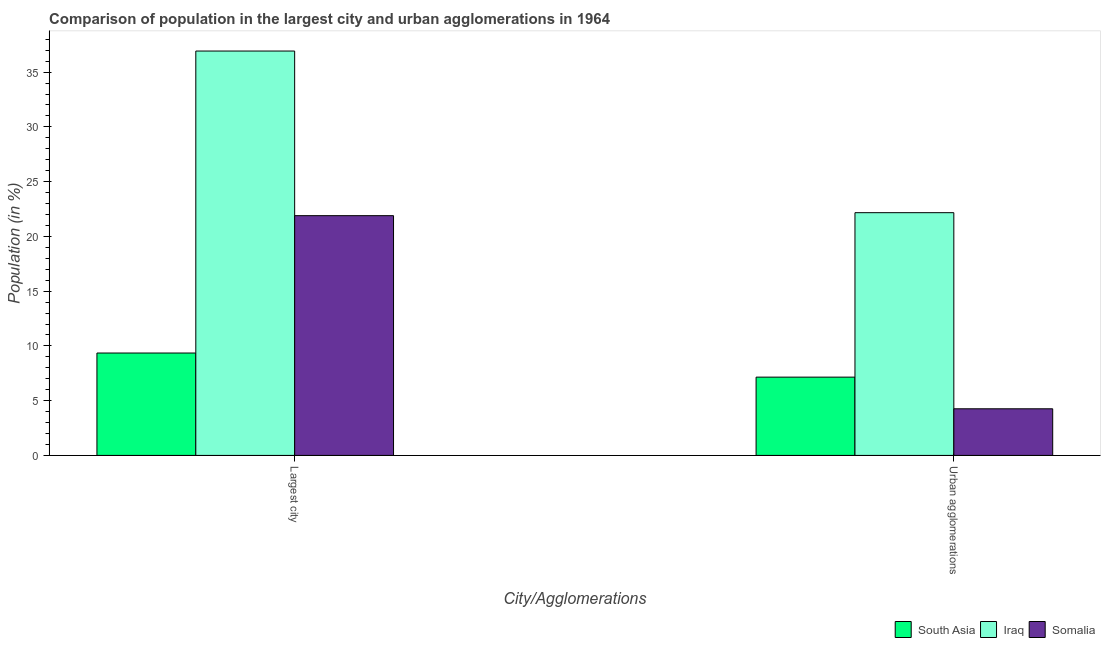How many different coloured bars are there?
Offer a very short reply. 3. How many groups of bars are there?
Give a very brief answer. 2. How many bars are there on the 2nd tick from the left?
Keep it short and to the point. 3. How many bars are there on the 2nd tick from the right?
Provide a short and direct response. 3. What is the label of the 1st group of bars from the left?
Give a very brief answer. Largest city. What is the population in urban agglomerations in Iraq?
Give a very brief answer. 22.17. Across all countries, what is the maximum population in the largest city?
Provide a short and direct response. 36.92. Across all countries, what is the minimum population in urban agglomerations?
Your answer should be compact. 4.26. In which country was the population in the largest city maximum?
Offer a very short reply. Iraq. In which country was the population in the largest city minimum?
Offer a very short reply. South Asia. What is the total population in urban agglomerations in the graph?
Your answer should be compact. 33.57. What is the difference between the population in urban agglomerations in Somalia and that in South Asia?
Offer a terse response. -2.89. What is the difference between the population in the largest city in Somalia and the population in urban agglomerations in South Asia?
Ensure brevity in your answer.  14.74. What is the average population in the largest city per country?
Your answer should be very brief. 22.72. What is the difference between the population in the largest city and population in urban agglomerations in Somalia?
Your answer should be compact. 17.63. What is the ratio of the population in urban agglomerations in Iraq to that in Somalia?
Ensure brevity in your answer.  5.2. In how many countries, is the population in the largest city greater than the average population in the largest city taken over all countries?
Offer a very short reply. 1. What does the 2nd bar from the left in Urban agglomerations represents?
Keep it short and to the point. Iraq. What does the 2nd bar from the right in Largest city represents?
Your response must be concise. Iraq. What is the difference between two consecutive major ticks on the Y-axis?
Make the answer very short. 5. Does the graph contain any zero values?
Provide a succinct answer. No. Does the graph contain grids?
Your answer should be compact. No. Where does the legend appear in the graph?
Offer a terse response. Bottom right. How are the legend labels stacked?
Your response must be concise. Horizontal. What is the title of the graph?
Provide a succinct answer. Comparison of population in the largest city and urban agglomerations in 1964. What is the label or title of the X-axis?
Give a very brief answer. City/Agglomerations. What is the Population (in %) of South Asia in Largest city?
Your response must be concise. 9.35. What is the Population (in %) in Iraq in Largest city?
Provide a short and direct response. 36.92. What is the Population (in %) of Somalia in Largest city?
Your answer should be very brief. 21.89. What is the Population (in %) of South Asia in Urban agglomerations?
Provide a short and direct response. 7.15. What is the Population (in %) of Iraq in Urban agglomerations?
Offer a very short reply. 22.17. What is the Population (in %) in Somalia in Urban agglomerations?
Your answer should be very brief. 4.26. Across all City/Agglomerations, what is the maximum Population (in %) of South Asia?
Give a very brief answer. 9.35. Across all City/Agglomerations, what is the maximum Population (in %) in Iraq?
Your answer should be very brief. 36.92. Across all City/Agglomerations, what is the maximum Population (in %) in Somalia?
Provide a succinct answer. 21.89. Across all City/Agglomerations, what is the minimum Population (in %) in South Asia?
Offer a terse response. 7.15. Across all City/Agglomerations, what is the minimum Population (in %) of Iraq?
Provide a succinct answer. 22.17. Across all City/Agglomerations, what is the minimum Population (in %) in Somalia?
Make the answer very short. 4.26. What is the total Population (in %) of South Asia in the graph?
Your response must be concise. 16.5. What is the total Population (in %) of Iraq in the graph?
Offer a very short reply. 59.09. What is the total Population (in %) in Somalia in the graph?
Offer a very short reply. 26.15. What is the difference between the Population (in %) in South Asia in Largest city and that in Urban agglomerations?
Keep it short and to the point. 2.2. What is the difference between the Population (in %) in Iraq in Largest city and that in Urban agglomerations?
Offer a very short reply. 14.76. What is the difference between the Population (in %) of Somalia in Largest city and that in Urban agglomerations?
Your response must be concise. 17.63. What is the difference between the Population (in %) in South Asia in Largest city and the Population (in %) in Iraq in Urban agglomerations?
Keep it short and to the point. -12.82. What is the difference between the Population (in %) in South Asia in Largest city and the Population (in %) in Somalia in Urban agglomerations?
Provide a succinct answer. 5.09. What is the difference between the Population (in %) in Iraq in Largest city and the Population (in %) in Somalia in Urban agglomerations?
Provide a succinct answer. 32.67. What is the average Population (in %) in South Asia per City/Agglomerations?
Offer a terse response. 8.25. What is the average Population (in %) of Iraq per City/Agglomerations?
Provide a succinct answer. 29.54. What is the average Population (in %) in Somalia per City/Agglomerations?
Provide a short and direct response. 13.08. What is the difference between the Population (in %) in South Asia and Population (in %) in Iraq in Largest city?
Give a very brief answer. -27.57. What is the difference between the Population (in %) in South Asia and Population (in %) in Somalia in Largest city?
Ensure brevity in your answer.  -12.54. What is the difference between the Population (in %) in Iraq and Population (in %) in Somalia in Largest city?
Offer a very short reply. 15.03. What is the difference between the Population (in %) in South Asia and Population (in %) in Iraq in Urban agglomerations?
Provide a short and direct response. -15.02. What is the difference between the Population (in %) of South Asia and Population (in %) of Somalia in Urban agglomerations?
Offer a very short reply. 2.89. What is the difference between the Population (in %) in Iraq and Population (in %) in Somalia in Urban agglomerations?
Your response must be concise. 17.91. What is the ratio of the Population (in %) of South Asia in Largest city to that in Urban agglomerations?
Ensure brevity in your answer.  1.31. What is the ratio of the Population (in %) of Iraq in Largest city to that in Urban agglomerations?
Your answer should be compact. 1.67. What is the ratio of the Population (in %) in Somalia in Largest city to that in Urban agglomerations?
Give a very brief answer. 5.14. What is the difference between the highest and the second highest Population (in %) in South Asia?
Your response must be concise. 2.2. What is the difference between the highest and the second highest Population (in %) in Iraq?
Offer a terse response. 14.76. What is the difference between the highest and the second highest Population (in %) of Somalia?
Your answer should be very brief. 17.63. What is the difference between the highest and the lowest Population (in %) in South Asia?
Provide a short and direct response. 2.2. What is the difference between the highest and the lowest Population (in %) in Iraq?
Offer a very short reply. 14.76. What is the difference between the highest and the lowest Population (in %) of Somalia?
Provide a short and direct response. 17.63. 